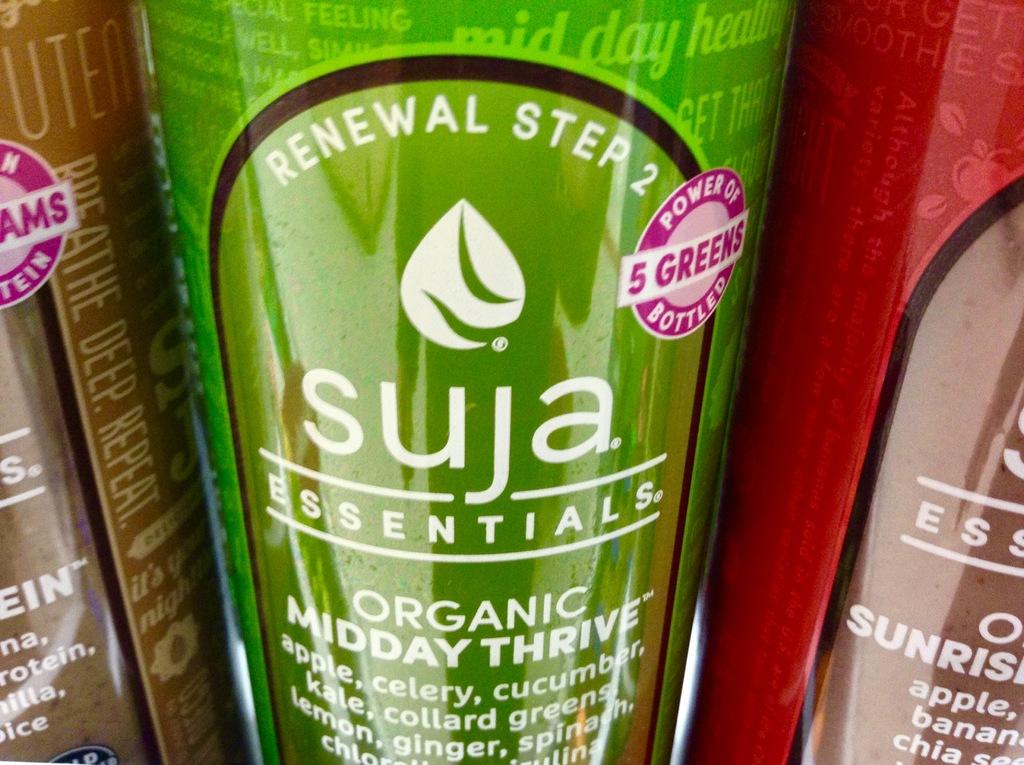What step is the green bottle?
Make the answer very short. 2. 